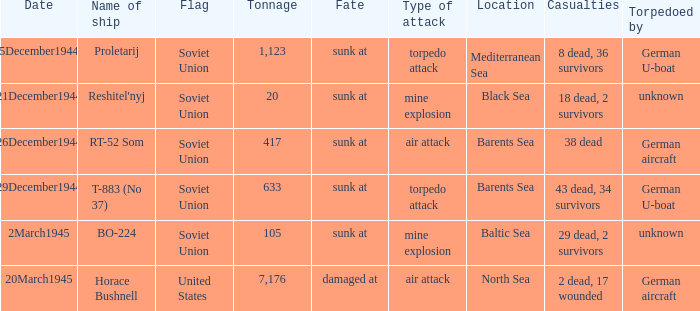How did the ship named proletarij finish its service? Sunk at. 